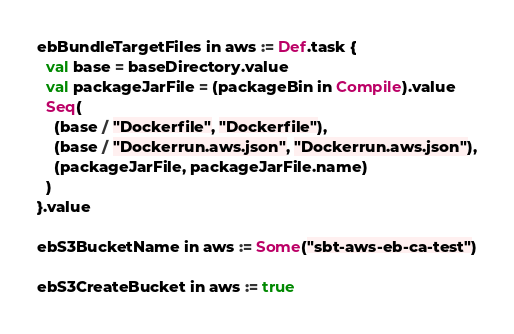<code> <loc_0><loc_0><loc_500><loc_500><_Scala_>
ebBundleTargetFiles in aws := Def.task {
  val base = baseDirectory.value
  val packageJarFile = (packageBin in Compile).value
  Seq(
    (base / "Dockerfile", "Dockerfile"),
    (base / "Dockerrun.aws.json", "Dockerrun.aws.json"),
    (packageJarFile, packageJarFile.name)
  )
}.value

ebS3BucketName in aws := Some("sbt-aws-eb-ca-test")

ebS3CreateBucket in aws := true</code> 